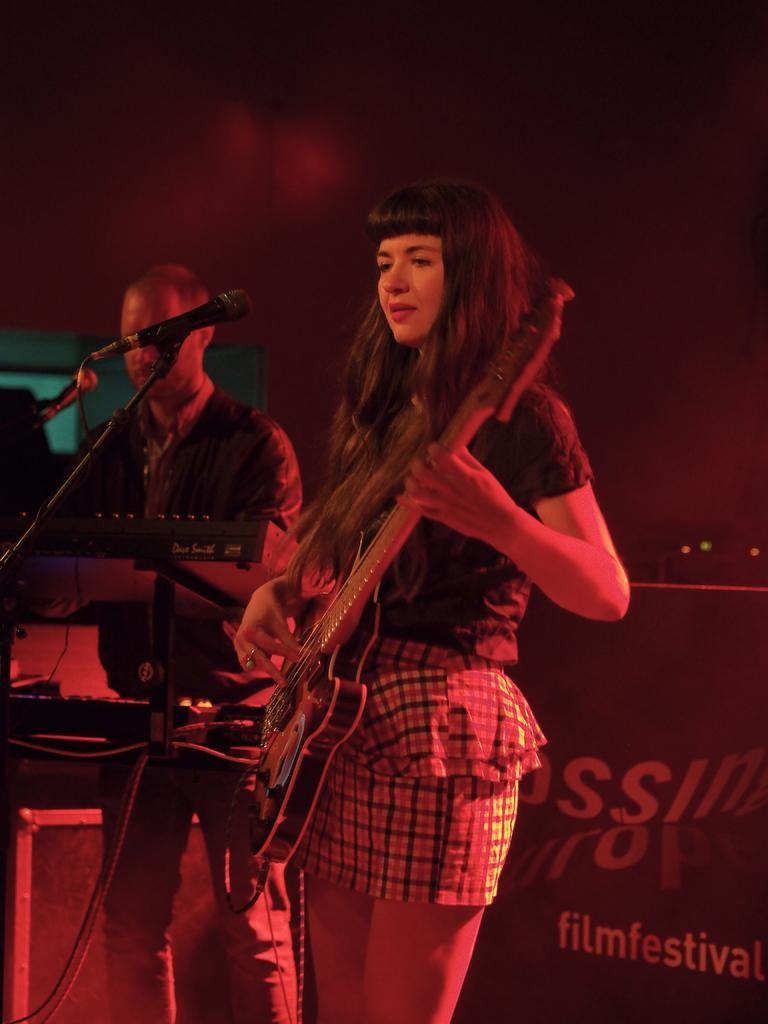Please provide a concise description of this image. This picture shows a woman standing and playing guitar and we see a microphone in front of her and we see a man standing and playing piano on the side and we see a hoarding on their back 